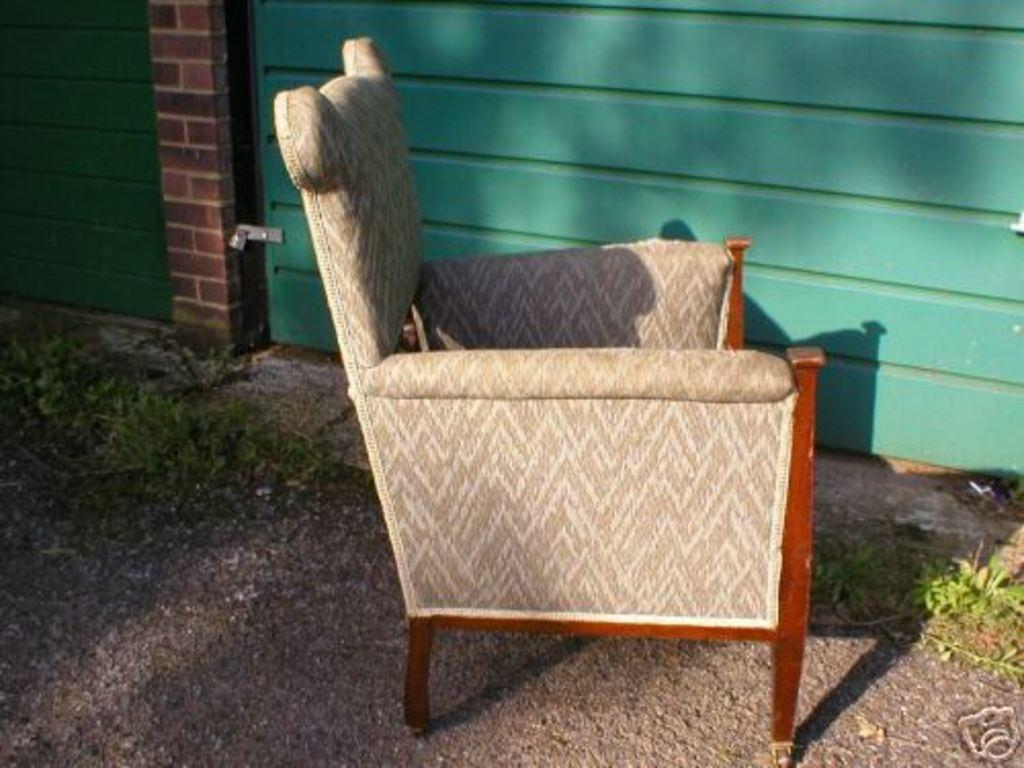What color is the shutter in the image? The shutter in the image is green. Where is the chair located in the image? The chair is on the road in the image. What type of vegetation is visible in the image? Grass is visible in the image. How many babies are shown in the advertisement in the image? There is no advertisement or babies present in the image. What are the brothers doing in the image? There are no brothers present in the image. 